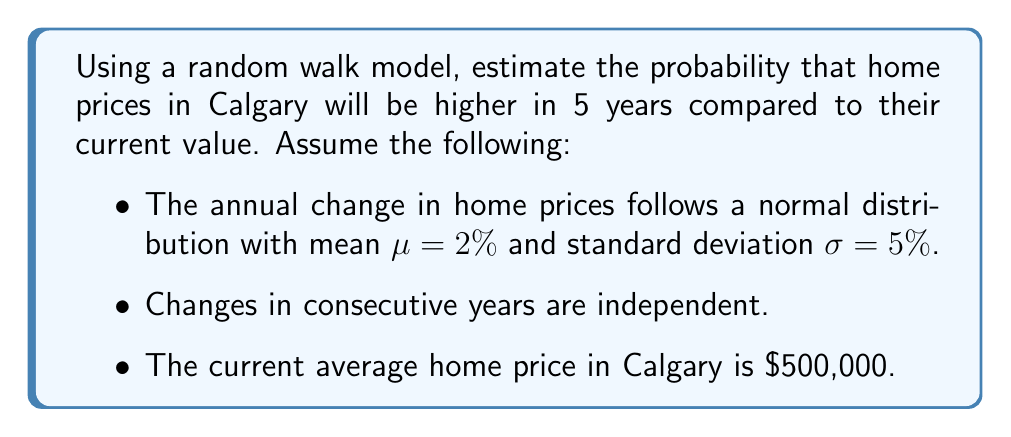Show me your answer to this math problem. To solve this problem, we'll use the properties of random walks and the central limit theorem:

1) In a random walk model, the total change over 5 years is the sum of 5 independent annual changes.

2) The sum of independent normally distributed random variables is also normally distributed.

3) For the 5-year period:
   Mean change: $\mu_{5} = 5 \cdot 2\% = 10\%$
   Variance: $\sigma_{5}^2 = 5 \cdot (5\%)^2 = 1.25\%^2$
   Standard deviation: $\sigma_{5} = \sqrt{1.25\%^2} = 7.91\%$

4) The probability of prices being higher is equivalent to the probability of the 5-year change being positive.

5) We can standardize this to a Z-score:
   $Z = \frac{0 - \mu_{5}}{\sigma_{5}} = \frac{0 - 10\%}{7.91\%} = -1.26$

6) The probability of being higher is the area to the right of Z = -1.26 on a standard normal distribution.

7) Using a standard normal table or calculator:
   $P(Z > -1.26) = 1 - P(Z < -1.26) = 1 - 0.1038 = 0.8962$

Therefore, there is approximately an 89.62% chance that home prices in Calgary will be higher in 5 years.
Answer: 89.62% 